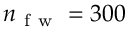Convert formula to latex. <formula><loc_0><loc_0><loc_500><loc_500>n _ { f w } = 3 0 0</formula> 